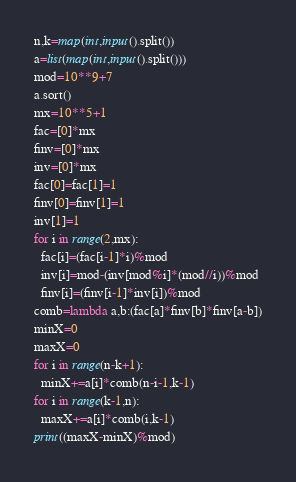Convert code to text. <code><loc_0><loc_0><loc_500><loc_500><_Python_>n,k=map(int,input().split())
a=list(map(int,input().split()))
mod=10**9+7
a.sort()
mx=10**5+1
fac=[0]*mx
finv=[0]*mx
inv=[0]*mx
fac[0]=fac[1]=1
finv[0]=finv[1]=1
inv[1]=1
for i in range(2,mx):
  fac[i]=(fac[i-1]*i)%mod
  inv[i]=mod-(inv[mod%i]*(mod//i))%mod
  finv[i]=(finv[i-1]*inv[i])%mod
comb=lambda a,b:(fac[a]*finv[b]*finv[a-b])
minX=0
maxX=0
for i in range(n-k+1):
  minX+=a[i]*comb(n-i-1,k-1)
for i in range(k-1,n):
  maxX+=a[i]*comb(i,k-1)
print((maxX-minX)%mod)</code> 